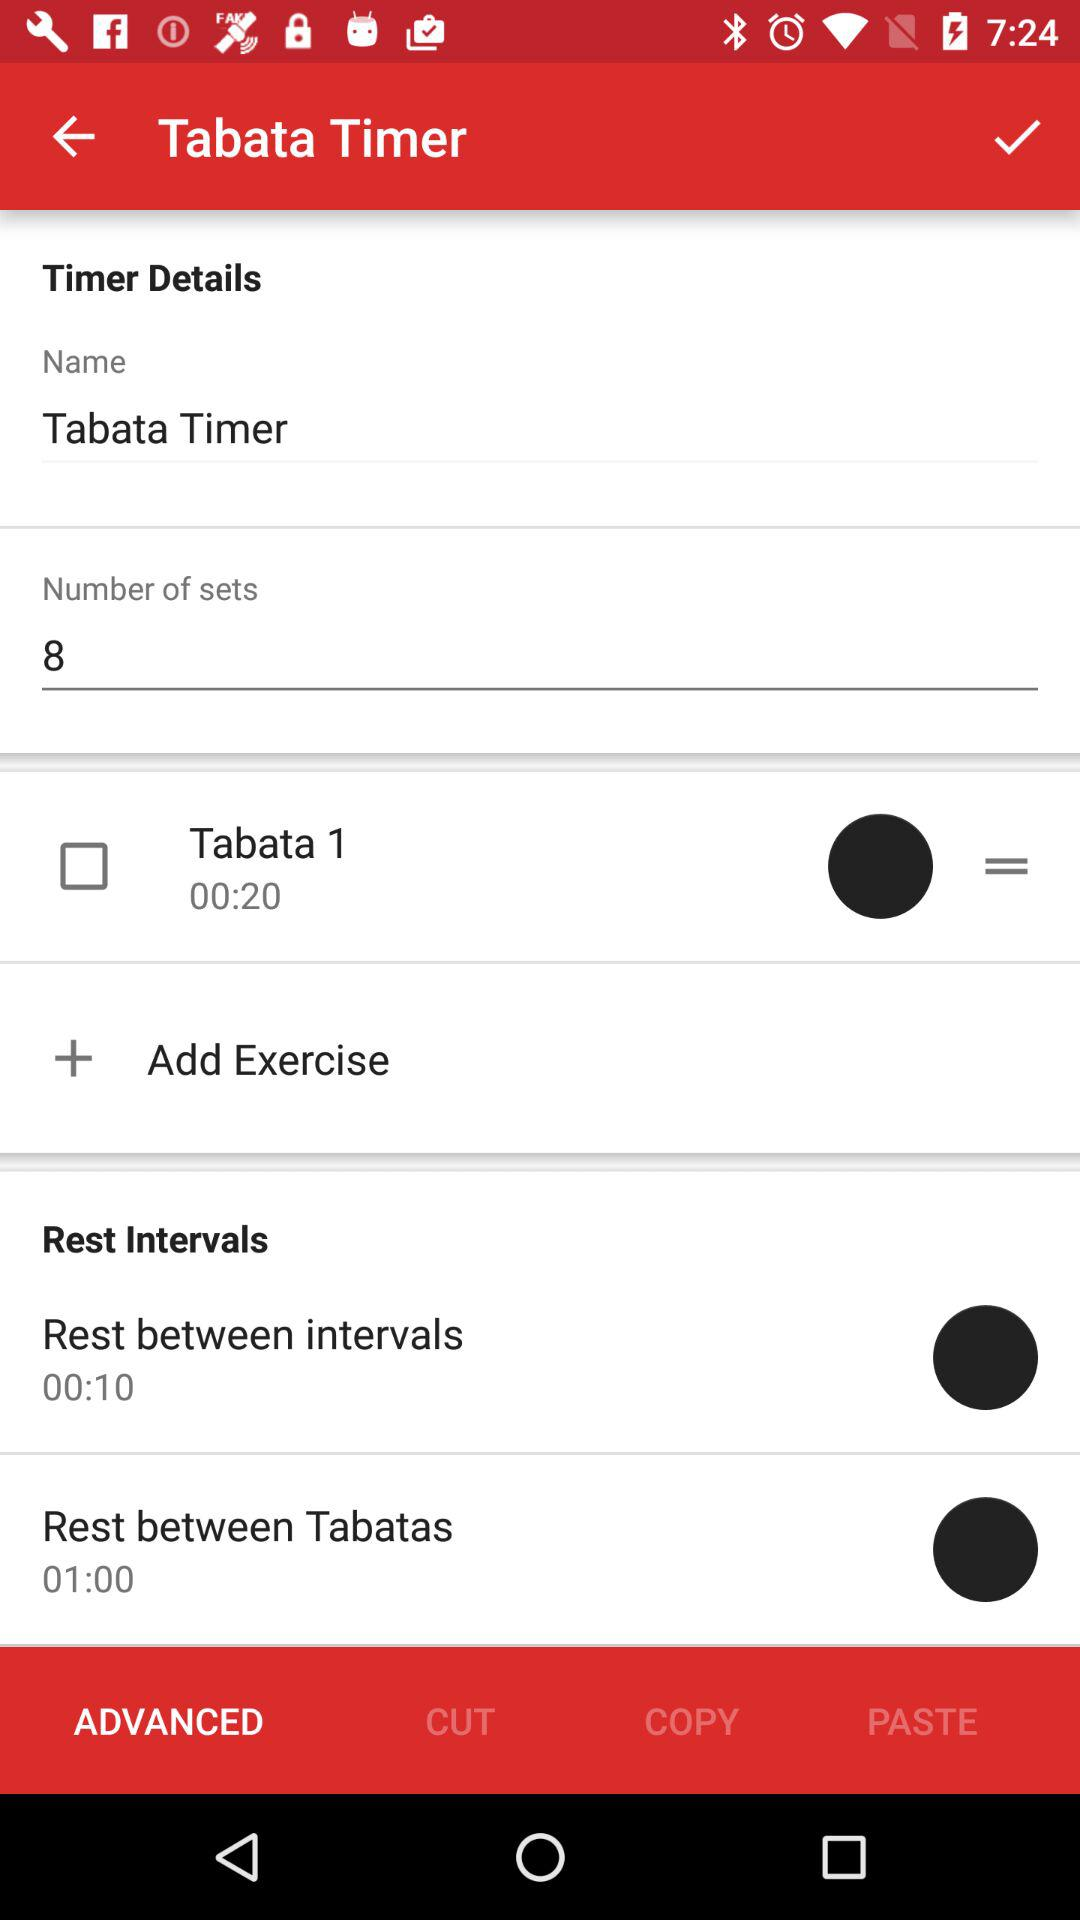How many sets are there? There are 8 sets. 